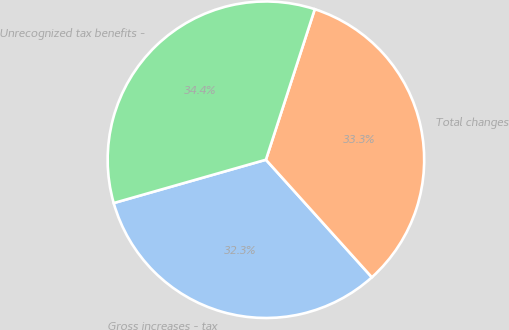<chart> <loc_0><loc_0><loc_500><loc_500><pie_chart><fcel>Gross increases - tax<fcel>Total changes<fcel>Unrecognized tax benefits -<nl><fcel>32.26%<fcel>33.33%<fcel>34.41%<nl></chart> 